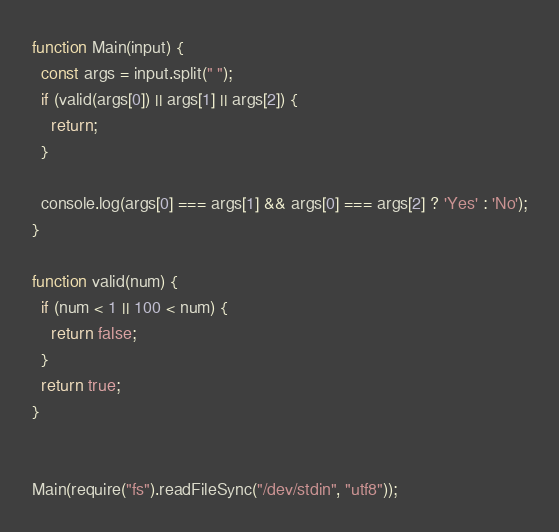Convert code to text. <code><loc_0><loc_0><loc_500><loc_500><_JavaScript_>function Main(input) {
  const args = input.split(" ");
  if (valid(args[0]) || args[1] || args[2]) {
    return;
  }

  console.log(args[0] === args[1] && args[0] === args[2] ? 'Yes' : 'No');
}

function valid(num) {
  if (num < 1 || 100 < num) {
    return false;
  }
  return true;
}


Main(require("fs").readFileSync("/dev/stdin", "utf8"));</code> 